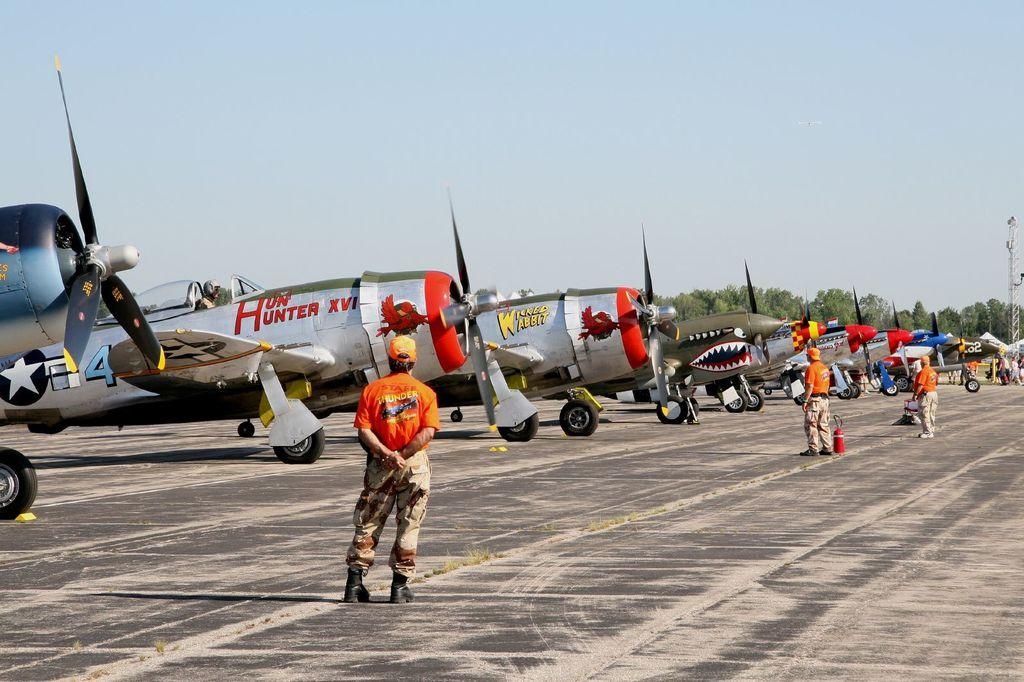What is the main subject of the picture? The main subject of the picture is airplanes. Where are the airplanes located in the picture? The airplanes are on the runway in the picture. What can be seen in the background of the picture? There are trees in the background of the picture. What is the condition of the sky in the picture? The sky is clear in the picture. Can you tell me how many snakes are slithering on the runway in the image? There are no snakes present in the image; it features airplanes on the runway. Who is the owner of the airplanes in the image? The image does not provide information about the ownership of the airplanes. 